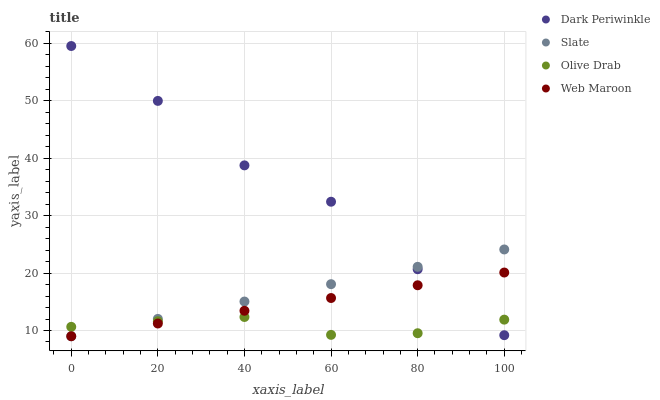Does Olive Drab have the minimum area under the curve?
Answer yes or no. Yes. Does Dark Periwinkle have the maximum area under the curve?
Answer yes or no. Yes. Does Web Maroon have the minimum area under the curve?
Answer yes or no. No. Does Web Maroon have the maximum area under the curve?
Answer yes or no. No. Is Slate the smoothest?
Answer yes or no. Yes. Is Dark Periwinkle the roughest?
Answer yes or no. Yes. Is Dark Periwinkle the smoothest?
Answer yes or no. No. Is Web Maroon the roughest?
Answer yes or no. No. Does Slate have the lowest value?
Answer yes or no. Yes. Does Dark Periwinkle have the lowest value?
Answer yes or no. No. Does Dark Periwinkle have the highest value?
Answer yes or no. Yes. Does Web Maroon have the highest value?
Answer yes or no. No. Does Dark Periwinkle intersect Olive Drab?
Answer yes or no. Yes. Is Dark Periwinkle less than Olive Drab?
Answer yes or no. No. Is Dark Periwinkle greater than Olive Drab?
Answer yes or no. No. 